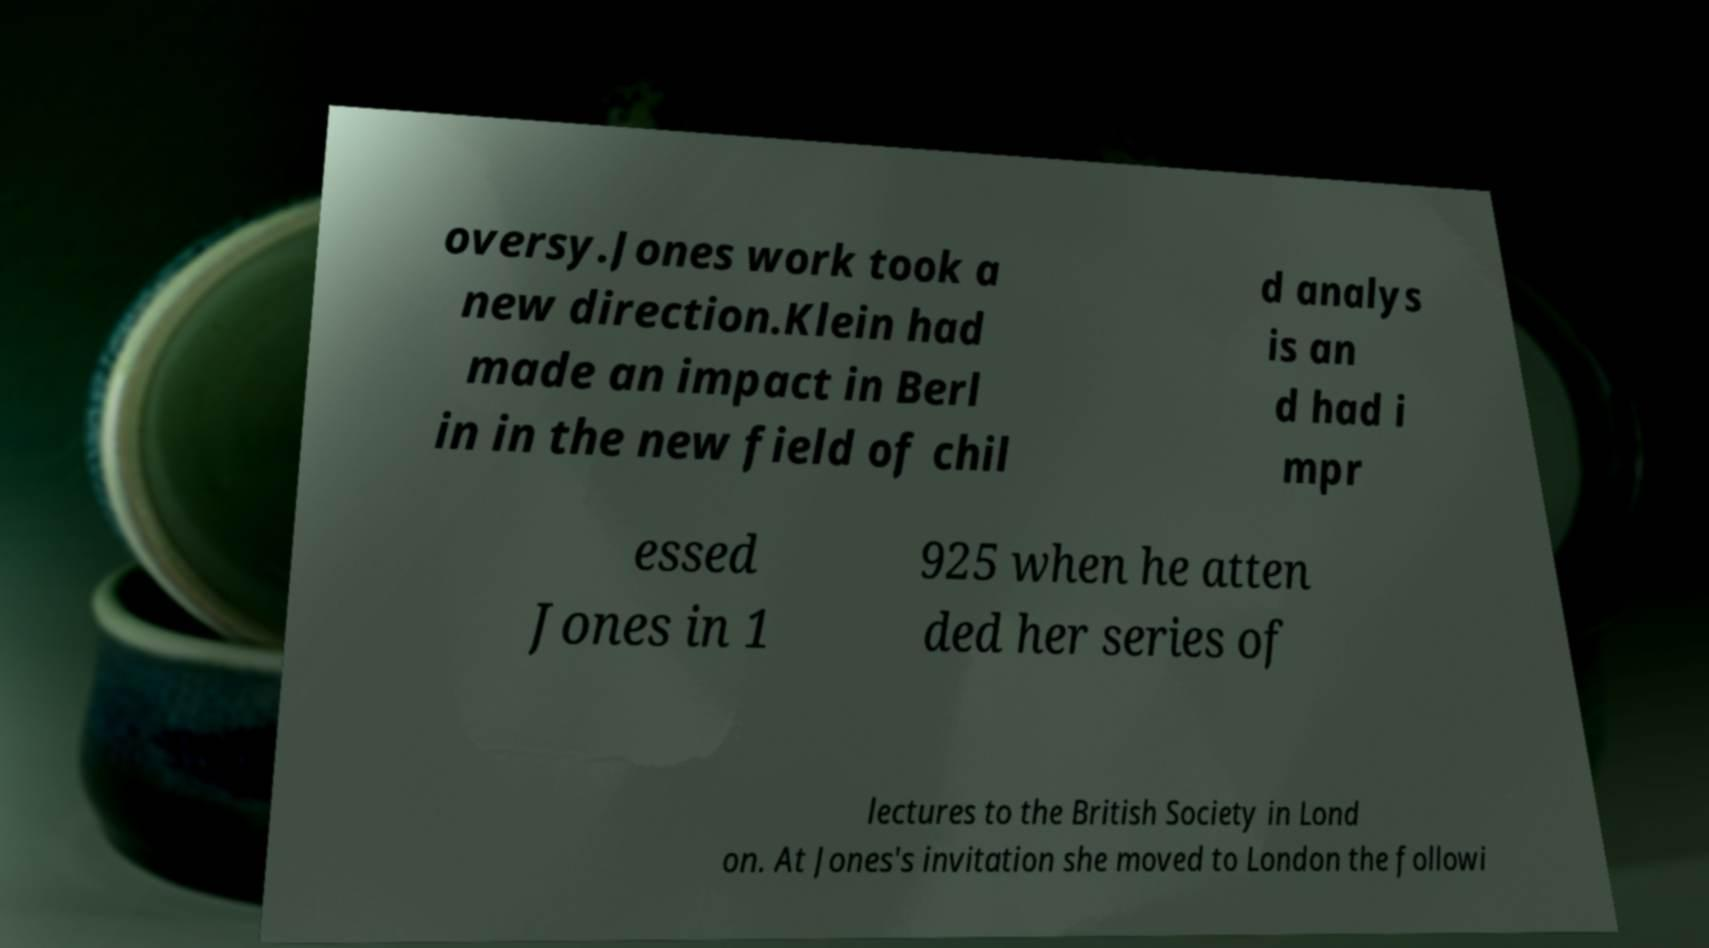What messages or text are displayed in this image? I need them in a readable, typed format. oversy.Jones work took a new direction.Klein had made an impact in Berl in in the new field of chil d analys is an d had i mpr essed Jones in 1 925 when he atten ded her series of lectures to the British Society in Lond on. At Jones's invitation she moved to London the followi 